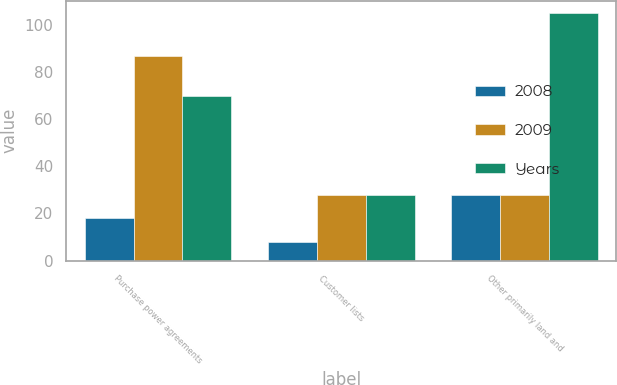<chart> <loc_0><loc_0><loc_500><loc_500><stacked_bar_chart><ecel><fcel>Purchase power agreements<fcel>Customer lists<fcel>Other primarily land and<nl><fcel>2008<fcel>18<fcel>8<fcel>28<nl><fcel>2009<fcel>87<fcel>28<fcel>28<nl><fcel>Years<fcel>70<fcel>28<fcel>105<nl></chart> 